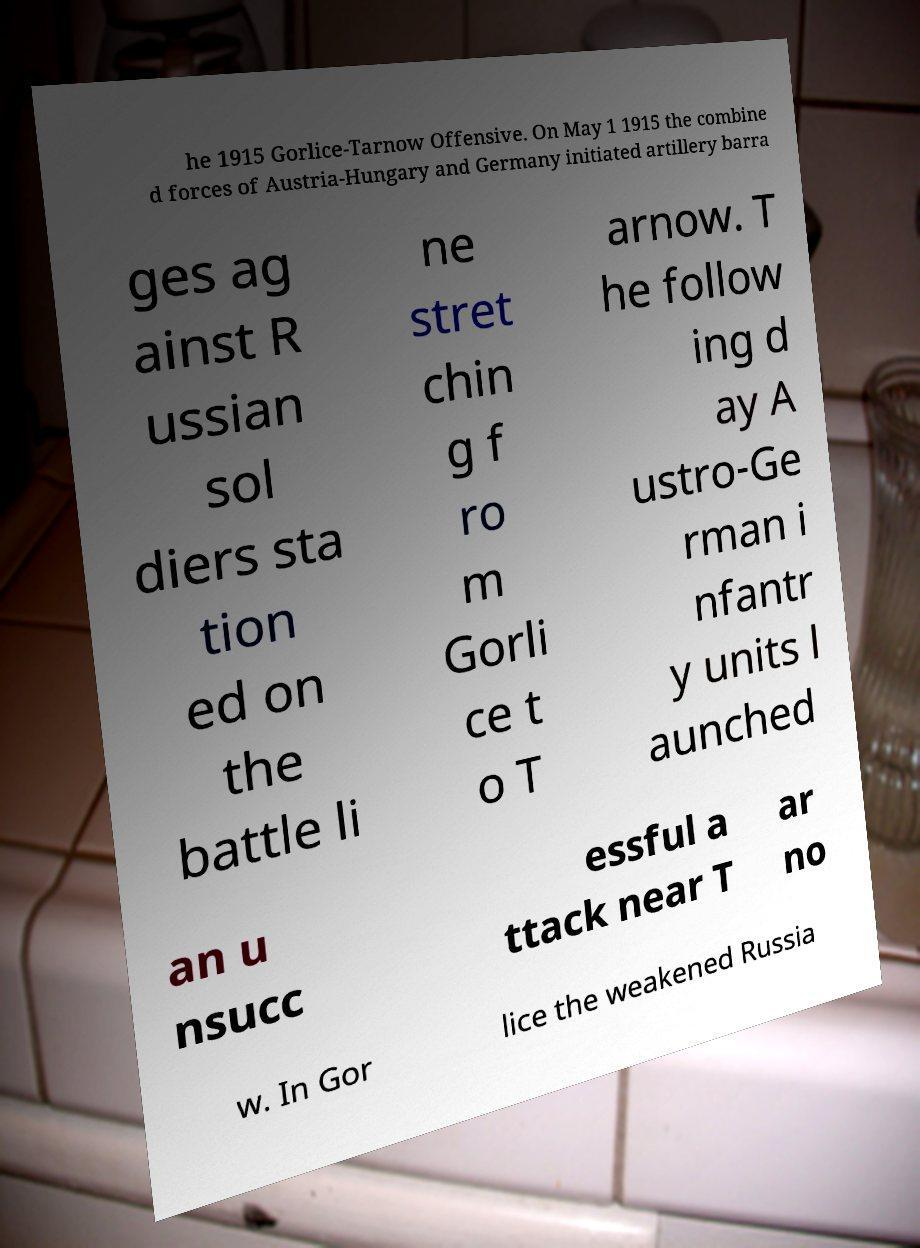For documentation purposes, I need the text within this image transcribed. Could you provide that? he 1915 Gorlice-Tarnow Offensive. On May 1 1915 the combine d forces of Austria-Hungary and Germany initiated artillery barra ges ag ainst R ussian sol diers sta tion ed on the battle li ne stret chin g f ro m Gorli ce t o T arnow. T he follow ing d ay A ustro-Ge rman i nfantr y units l aunched an u nsucc essful a ttack near T ar no w. In Gor lice the weakened Russia 